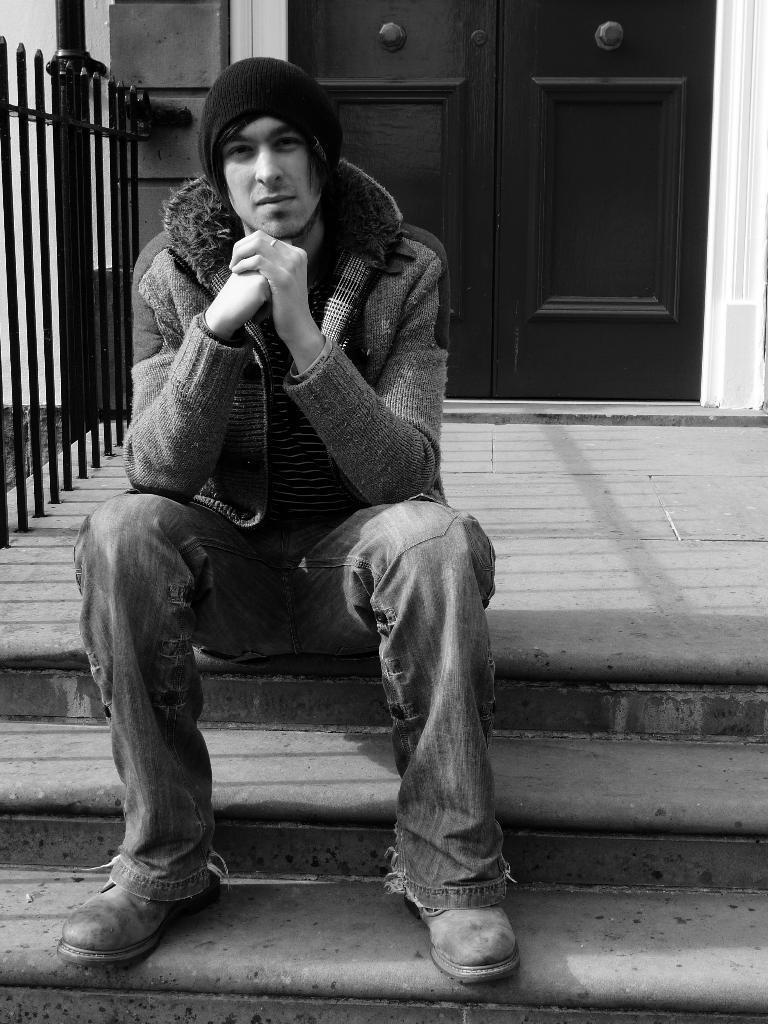Please provide a concise description of this image. In the image we can see there is a person sitting on the stairs, behind there is a door and the image is in black and white colour. 